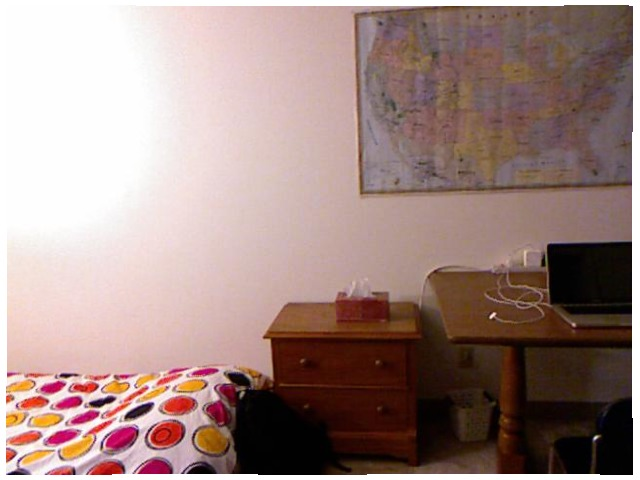<image>
Is there a map above the bed? No. The map is not positioned above the bed. The vertical arrangement shows a different relationship. Is the wall behind the picture? Yes. From this viewpoint, the wall is positioned behind the picture, with the picture partially or fully occluding the wall. Where is the bed in relation to the cupboard? Is it behind the cupboard? No. The bed is not behind the cupboard. From this viewpoint, the bed appears to be positioned elsewhere in the scene. Is the bed behind the drawer? No. The bed is not behind the drawer. From this viewpoint, the bed appears to be positioned elsewhere in the scene. 